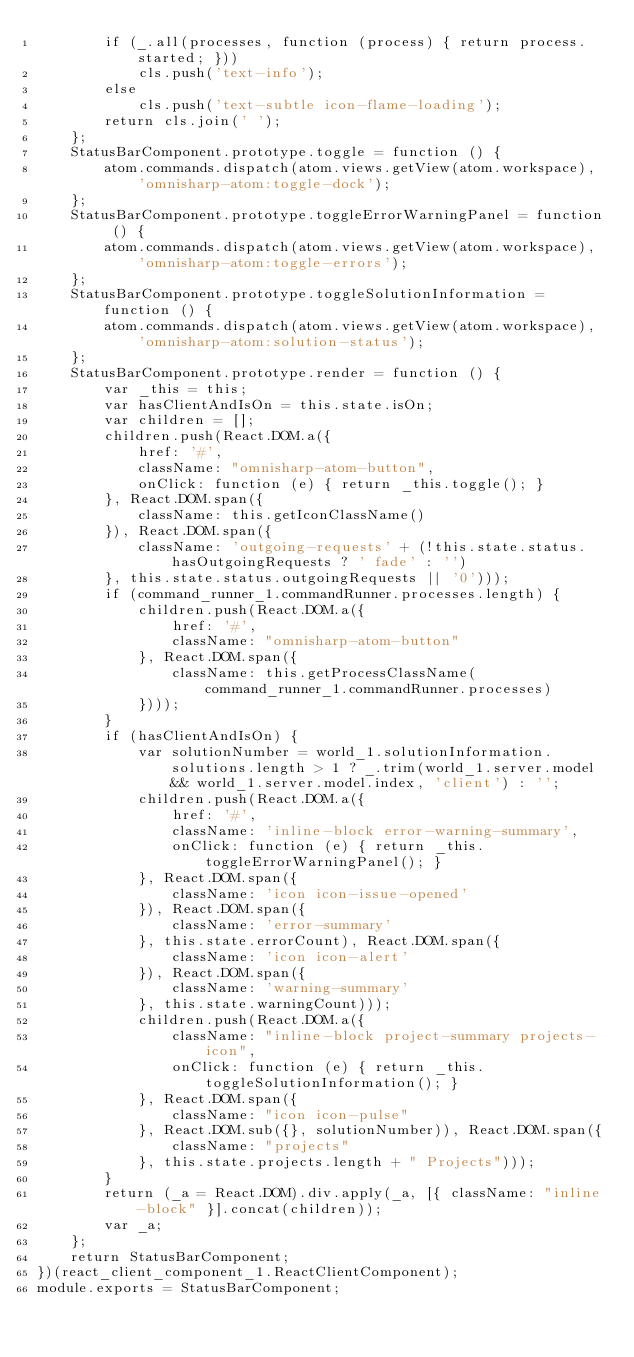Convert code to text. <code><loc_0><loc_0><loc_500><loc_500><_JavaScript_>        if (_.all(processes, function (process) { return process.started; }))
            cls.push('text-info');
        else
            cls.push('text-subtle icon-flame-loading');
        return cls.join(' ');
    };
    StatusBarComponent.prototype.toggle = function () {
        atom.commands.dispatch(atom.views.getView(atom.workspace), 'omnisharp-atom:toggle-dock');
    };
    StatusBarComponent.prototype.toggleErrorWarningPanel = function () {
        atom.commands.dispatch(atom.views.getView(atom.workspace), 'omnisharp-atom:toggle-errors');
    };
    StatusBarComponent.prototype.toggleSolutionInformation = function () {
        atom.commands.dispatch(atom.views.getView(atom.workspace), 'omnisharp-atom:solution-status');
    };
    StatusBarComponent.prototype.render = function () {
        var _this = this;
        var hasClientAndIsOn = this.state.isOn;
        var children = [];
        children.push(React.DOM.a({
            href: '#',
            className: "omnisharp-atom-button",
            onClick: function (e) { return _this.toggle(); }
        }, React.DOM.span({
            className: this.getIconClassName()
        }), React.DOM.span({
            className: 'outgoing-requests' + (!this.state.status.hasOutgoingRequests ? ' fade' : '')
        }, this.state.status.outgoingRequests || '0')));
        if (command_runner_1.commandRunner.processes.length) {
            children.push(React.DOM.a({
                href: '#',
                className: "omnisharp-atom-button"
            }, React.DOM.span({
                className: this.getProcessClassName(command_runner_1.commandRunner.processes)
            })));
        }
        if (hasClientAndIsOn) {
            var solutionNumber = world_1.solutionInformation.solutions.length > 1 ? _.trim(world_1.server.model && world_1.server.model.index, 'client') : '';
            children.push(React.DOM.a({
                href: '#',
                className: 'inline-block error-warning-summary',
                onClick: function (e) { return _this.toggleErrorWarningPanel(); }
            }, React.DOM.span({
                className: 'icon icon-issue-opened'
            }), React.DOM.span({
                className: 'error-summary'
            }, this.state.errorCount), React.DOM.span({
                className: 'icon icon-alert'
            }), React.DOM.span({
                className: 'warning-summary'
            }, this.state.warningCount)));
            children.push(React.DOM.a({
                className: "inline-block project-summary projects-icon",
                onClick: function (e) { return _this.toggleSolutionInformation(); }
            }, React.DOM.span({
                className: "icon icon-pulse"
            }, React.DOM.sub({}, solutionNumber)), React.DOM.span({
                className: "projects"
            }, this.state.projects.length + " Projects")));
        }
        return (_a = React.DOM).div.apply(_a, [{ className: "inline-block" }].concat(children));
        var _a;
    };
    return StatusBarComponent;
})(react_client_component_1.ReactClientComponent);
module.exports = StatusBarComponent;
</code> 